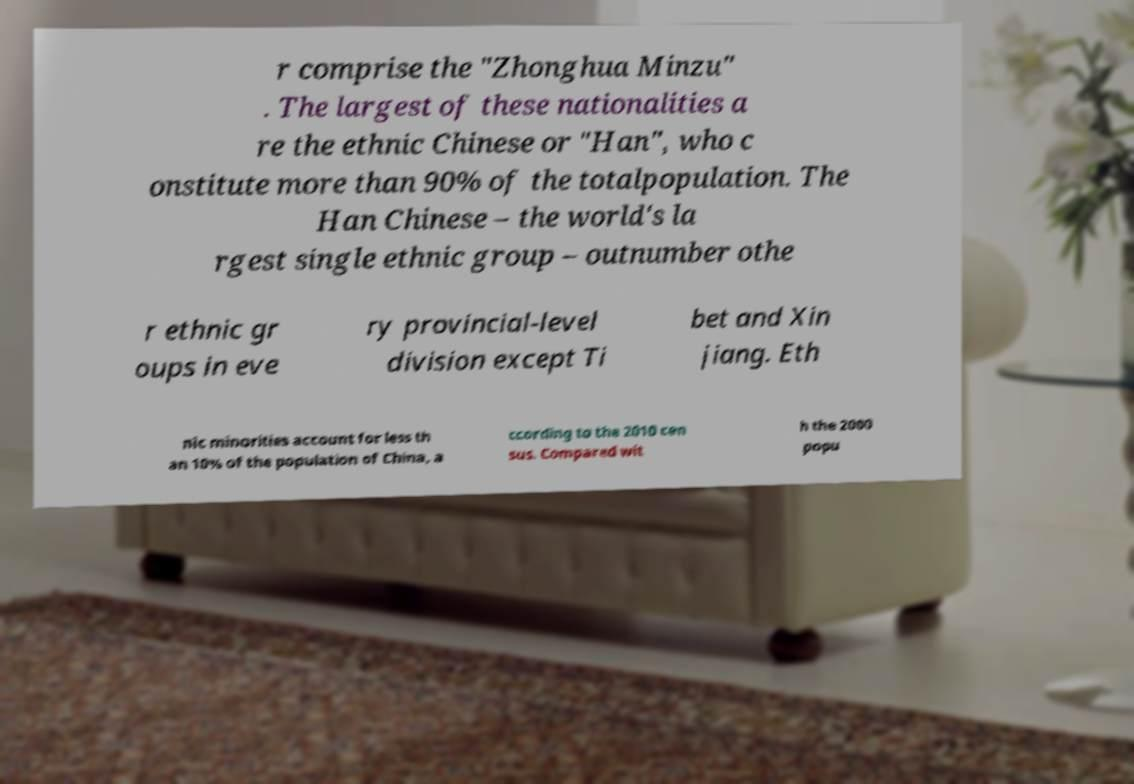For documentation purposes, I need the text within this image transcribed. Could you provide that? r comprise the "Zhonghua Minzu" . The largest of these nationalities a re the ethnic Chinese or "Han", who c onstitute more than 90% of the totalpopulation. The Han Chinese – the world's la rgest single ethnic group – outnumber othe r ethnic gr oups in eve ry provincial-level division except Ti bet and Xin jiang. Eth nic minorities account for less th an 10% of the population of China, a ccording to the 2010 cen sus. Compared wit h the 2000 popu 